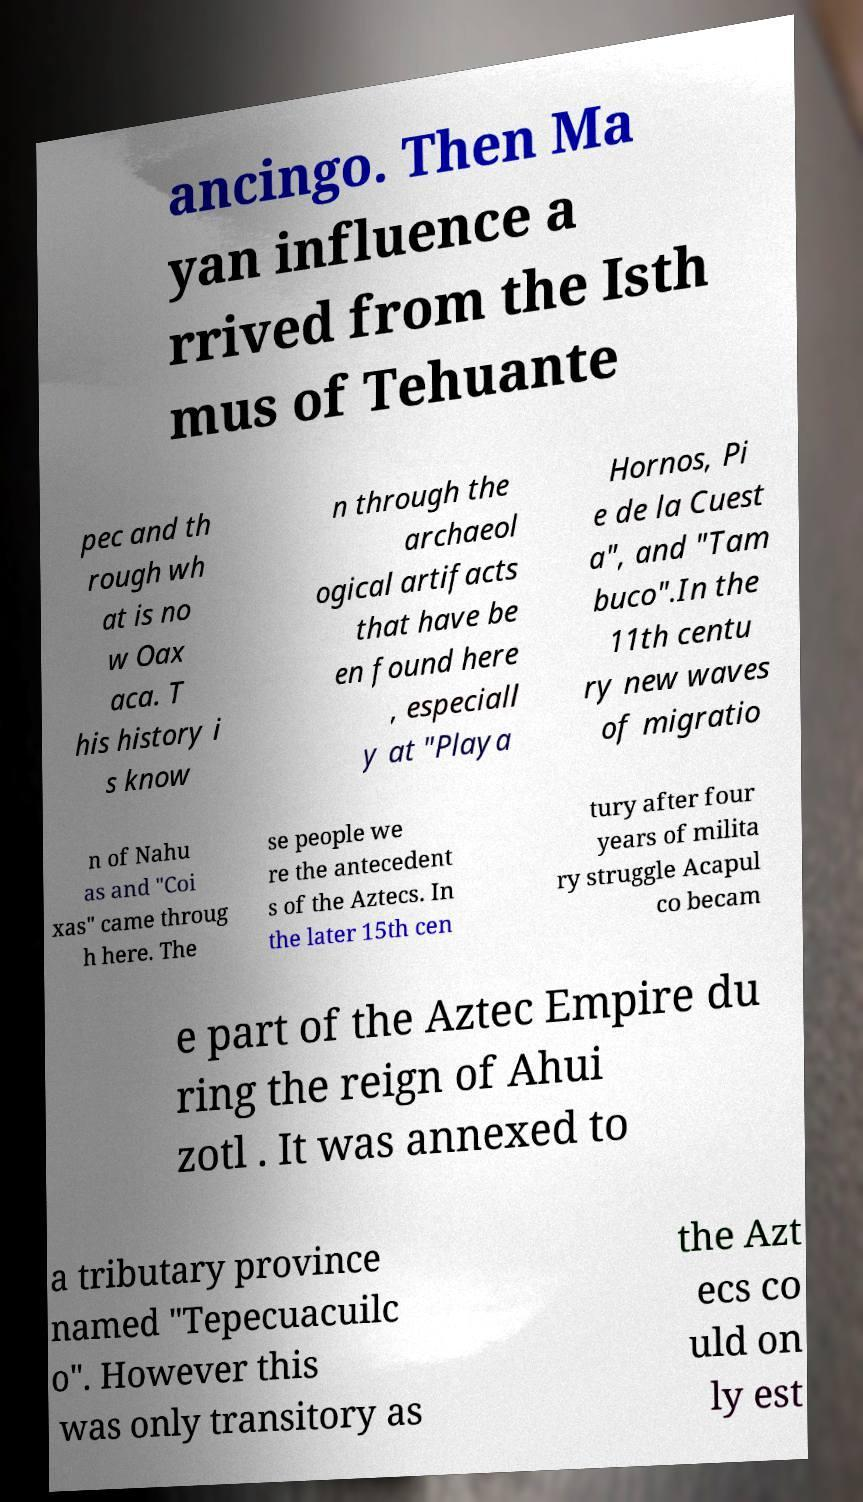Please identify and transcribe the text found in this image. ancingo. Then Ma yan influence a rrived from the Isth mus of Tehuante pec and th rough wh at is no w Oax aca. T his history i s know n through the archaeol ogical artifacts that have be en found here , especiall y at "Playa Hornos, Pi e de la Cuest a", and "Tam buco".In the 11th centu ry new waves of migratio n of Nahu as and "Coi xas" came throug h here. The se people we re the antecedent s of the Aztecs. In the later 15th cen tury after four years of milita ry struggle Acapul co becam e part of the Aztec Empire du ring the reign of Ahui zotl . It was annexed to a tributary province named "Tepecuacuilc o". However this was only transitory as the Azt ecs co uld on ly est 